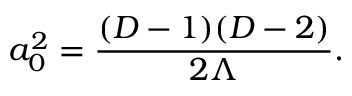Convert formula to latex. <formula><loc_0><loc_0><loc_500><loc_500>a _ { 0 } ^ { 2 } = { \frac { ( D - 1 ) ( D - 2 ) } { 2 \Lambda } } .</formula> 